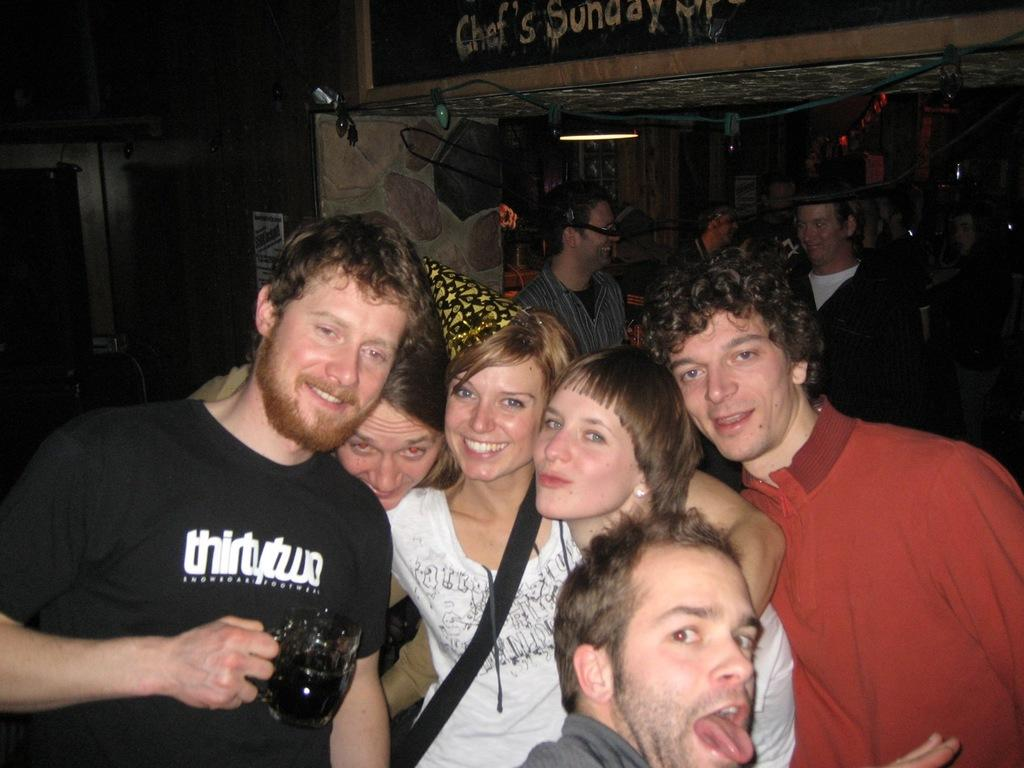<image>
Create a compact narrative representing the image presented. Group of people standing under a sign that read Chef's Sunday. 